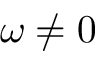Convert formula to latex. <formula><loc_0><loc_0><loc_500><loc_500>\omega \neq 0</formula> 